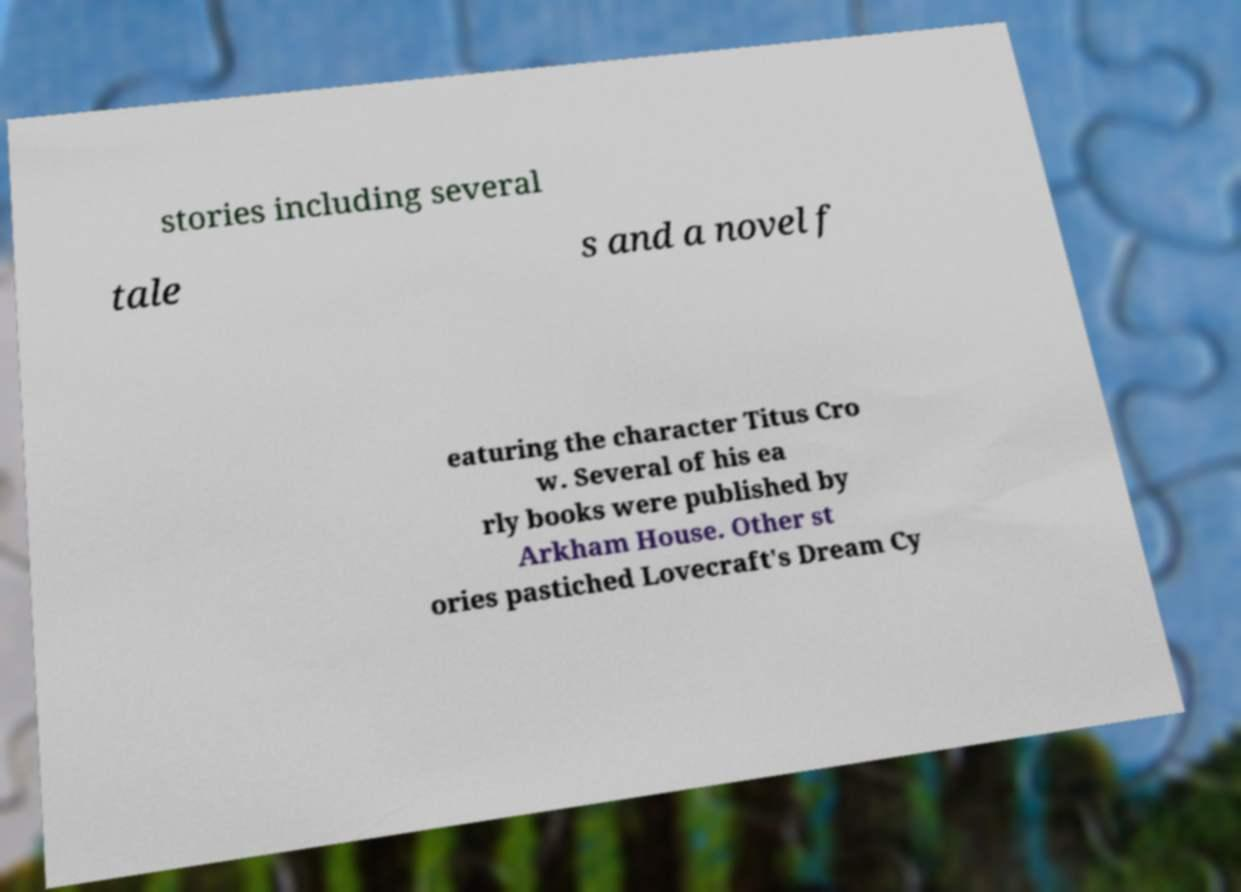Could you assist in decoding the text presented in this image and type it out clearly? stories including several tale s and a novel f eaturing the character Titus Cro w. Several of his ea rly books were published by Arkham House. Other st ories pastiched Lovecraft's Dream Cy 